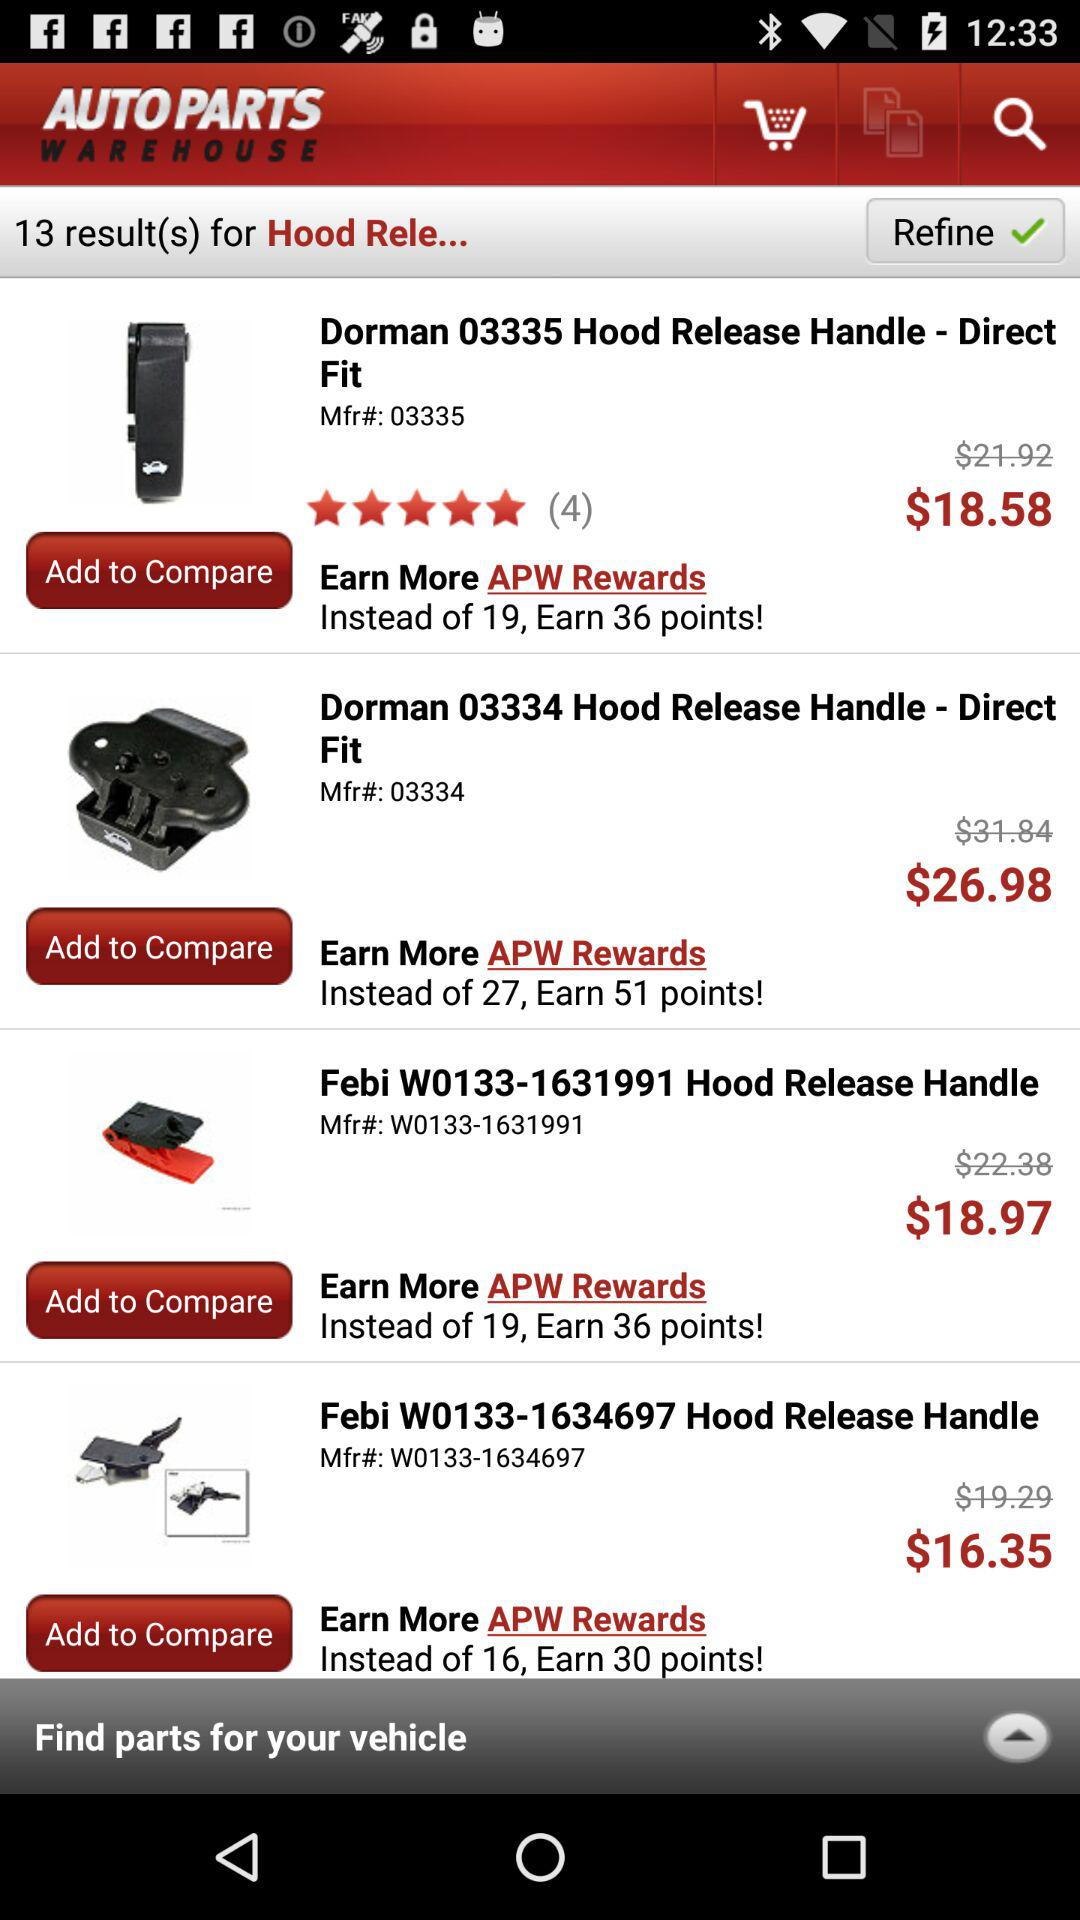What is the discounted price of "Febi W0133-1634697"? The discounted price is $16.35. 